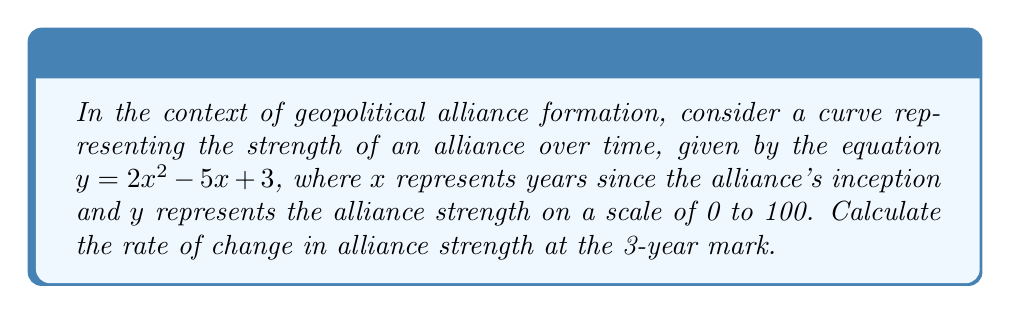Solve this math problem. To find the rate of change in alliance strength at the 3-year mark, we need to calculate the slope of the tangent line to the curve at $x = 3$. This is equivalent to finding the derivative of the function at $x = 3$.

Step 1: Find the derivative of the function.
The function is $y = 2x^2 - 5x + 3$
The derivative is $\frac{dy}{dx} = 4x - 5$

Step 2: Evaluate the derivative at $x = 3$.
$\frac{dy}{dx}|_{x=3} = 4(3) - 5 = 12 - 5 = 7$

Therefore, the slope of the geopolitical alliance formation curve at the 3-year mark is 7, indicating that the alliance strength is increasing at a rate of 7 units per year at this point.
Answer: 7 